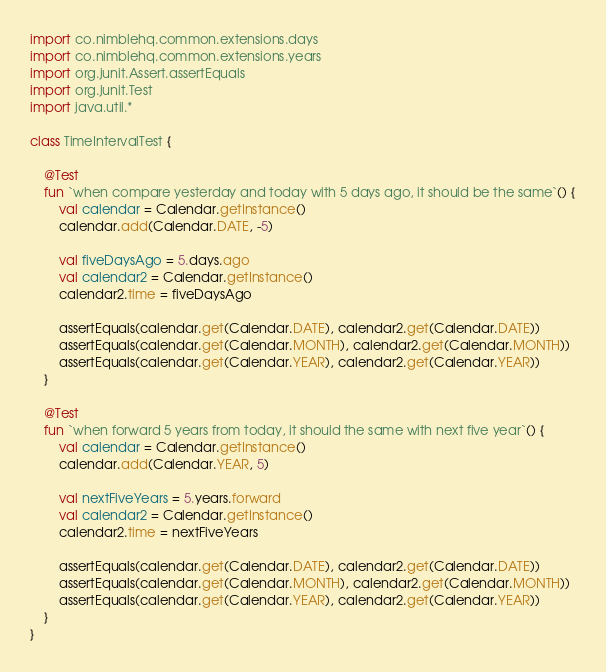Convert code to text. <code><loc_0><loc_0><loc_500><loc_500><_Kotlin_>
import co.nimblehq.common.extensions.days
import co.nimblehq.common.extensions.years
import org.junit.Assert.assertEquals
import org.junit.Test
import java.util.*

class TimeIntervalTest {

    @Test
    fun `when compare yesterday and today with 5 days ago, it should be the same`() {
        val calendar = Calendar.getInstance()
        calendar.add(Calendar.DATE, -5)

        val fiveDaysAgo = 5.days.ago
        val calendar2 = Calendar.getInstance()
        calendar2.time = fiveDaysAgo

        assertEquals(calendar.get(Calendar.DATE), calendar2.get(Calendar.DATE))
        assertEquals(calendar.get(Calendar.MONTH), calendar2.get(Calendar.MONTH))
        assertEquals(calendar.get(Calendar.YEAR), calendar2.get(Calendar.YEAR))
    }

    @Test
    fun `when forward 5 years from today, it should the same with next five year`() {
        val calendar = Calendar.getInstance()
        calendar.add(Calendar.YEAR, 5)

        val nextFiveYears = 5.years.forward
        val calendar2 = Calendar.getInstance()
        calendar2.time = nextFiveYears

        assertEquals(calendar.get(Calendar.DATE), calendar2.get(Calendar.DATE))
        assertEquals(calendar.get(Calendar.MONTH), calendar2.get(Calendar.MONTH))
        assertEquals(calendar.get(Calendar.YEAR), calendar2.get(Calendar.YEAR))
    }
}

</code> 